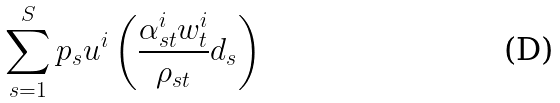<formula> <loc_0><loc_0><loc_500><loc_500>\sum _ { s = 1 } ^ { S } p _ { s } u ^ { i } \left ( \frac { \alpha _ { s t } ^ { i } w _ { t } ^ { i } } { \rho _ { s t } } d _ { s } \right )</formula> 